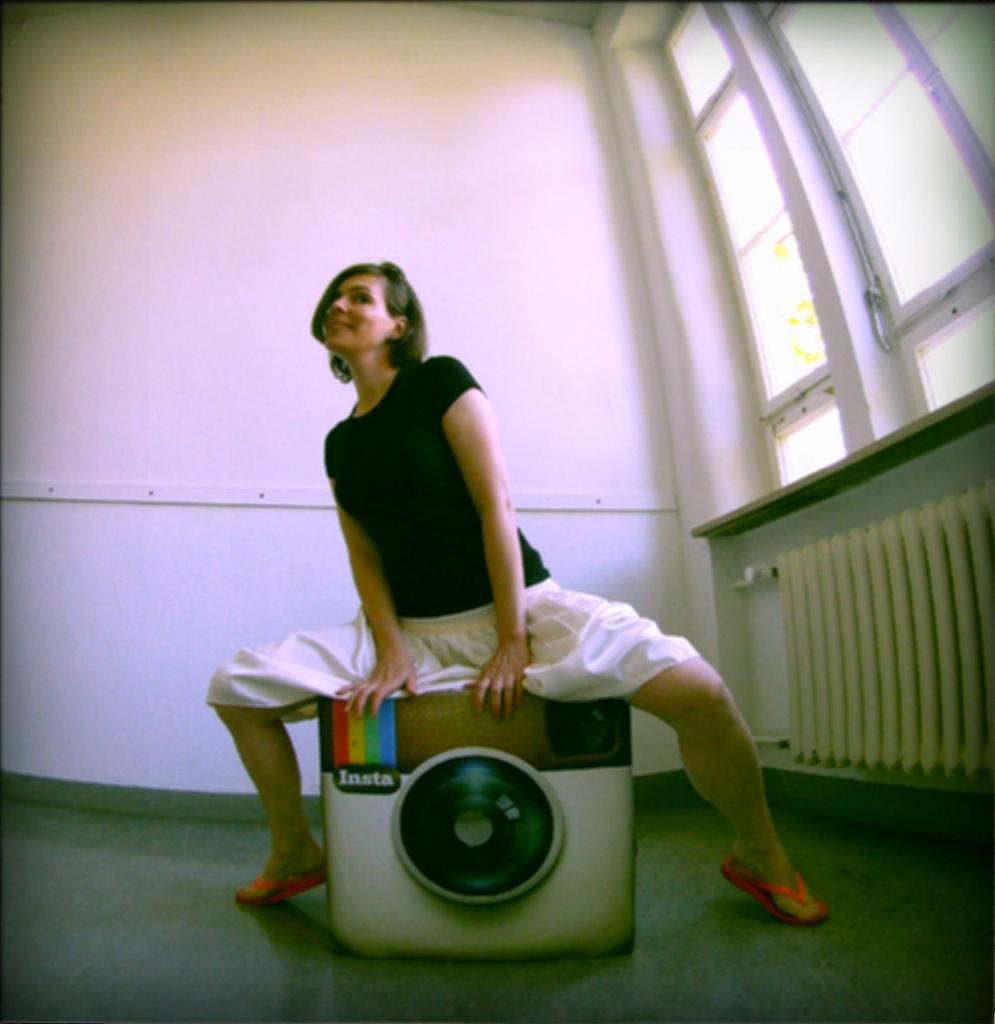Who is the main subject in the image? There is a woman in the image. What is the woman doing in the image? The woman is sitting on a stool in the image. Can you describe the stool's design? The stool is in the model of the Instagram icon. What can be seen in the background of the image? There is a window and a wall in the background of the image. What type of jelly is being used to hold the stool together in the image? There is no jelly present in the image, and the stool is not being held together with any adhesive. What time of day is it in the image, based on the hour? The provided facts do not mention the time of day or any hour-related information, so it cannot be determined from the image. 